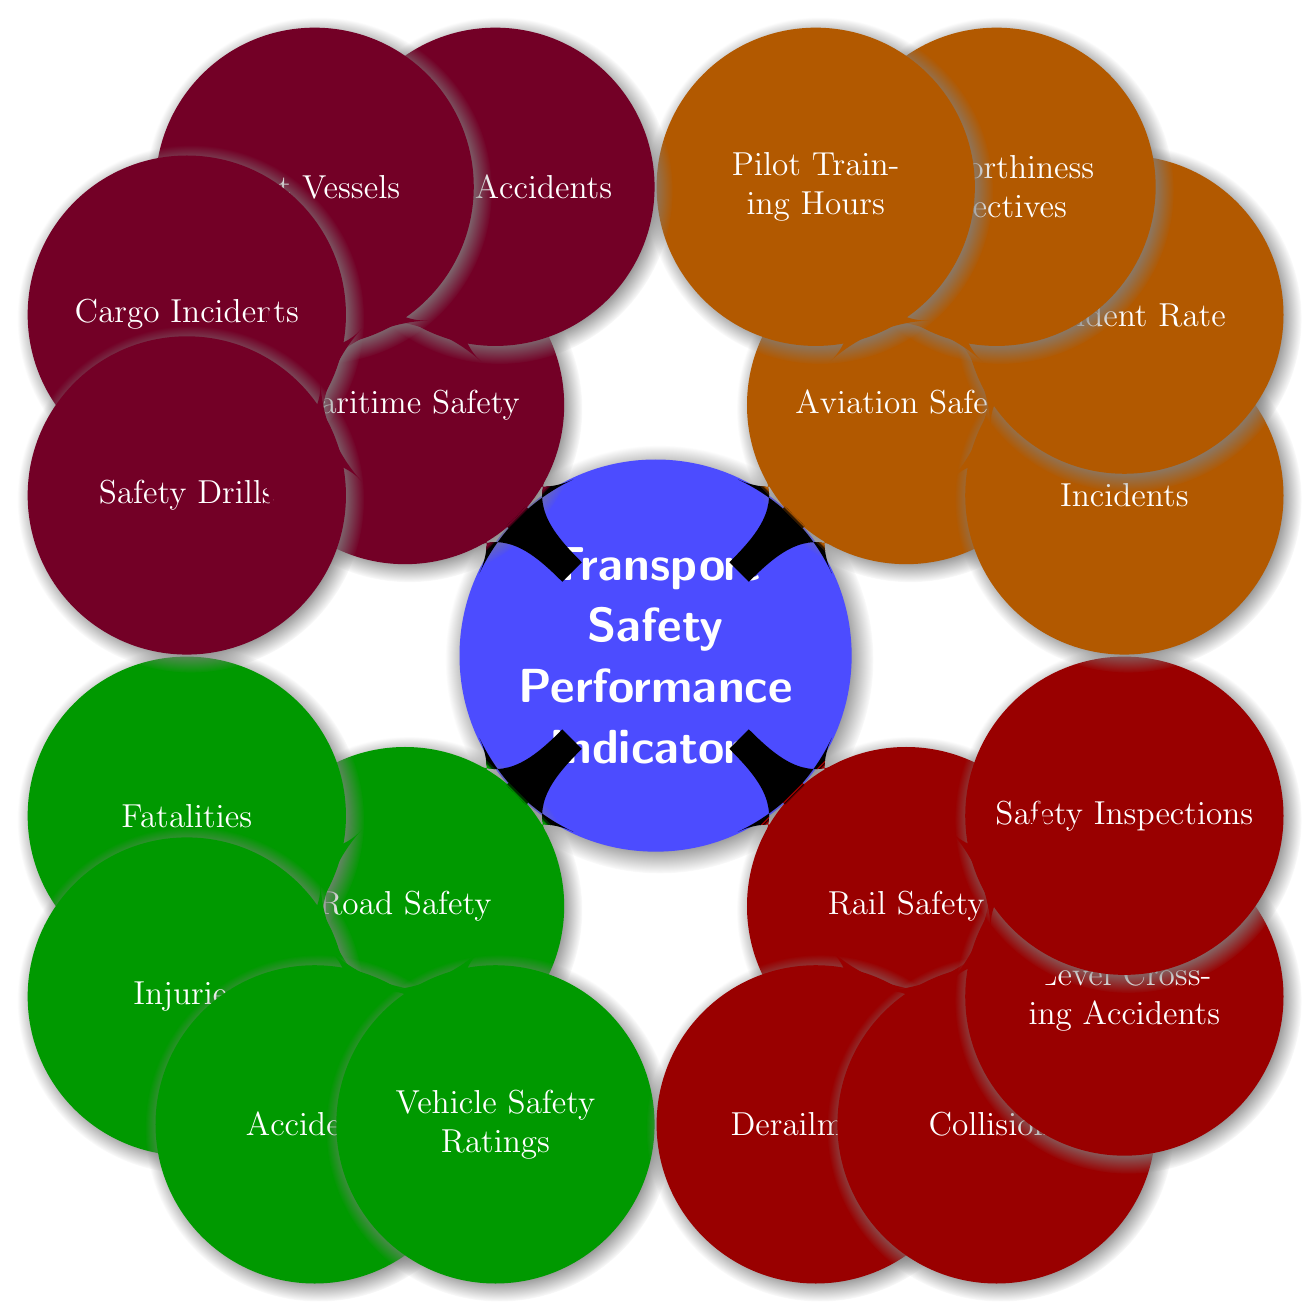What are the four categories of transport safety performance indicators? The mind map displays four main categories: Road Safety, Rail Safety, Aviation Safety, and Maritime Safety. These are the top-level nodes under the root concept.
Answer: Road Safety, Rail Safety, Aviation Safety, Maritime Safety How many indicators are associated with Road Safety? The Road Safety branch has four indicators listed: Fatalities, Injuries, Accidents, and Vehicle Safety Ratings. Therefore, the count of nodes under this category is four.
Answer: 4 What specific type of incident is measured under Rail Safety? There are several indicators under Rail Safety, one of which is "Collisions," which specifically measures train collisions per year. This is directly indicated in the Rail Safety category.
Answer: Collisions Which category includes the indicator for Pilot Training Hours? Pilot Training Hours is listed under the Aviation Safety category, indicating it pertains specifically to that mode of transportation. This information can be found in the Aviation Safety section of the mind map.
Answer: Aviation Safety How many unique indicators are listed for Maritime Safety? The Maritime Safety node includes four distinct indicators: Vessel Accidents, Lost Vessels, Cargo Incidents, and Safety Drills, totaling four unique indicators.
Answer: 4 What is the relationship between the indicator "Safety Inspections" and Rail Safety? "Safety Inspections" is one of the four indicators specifically under the Rail Safety category, indicating it is crucial for assessing the safety within the rail transport sector.
Answer: Safety Inspections is under Rail Safety What overall trends can be observed in terms of categories represented in the mind map? The mind map comprehensively represents four main modes of transport, each with its own set of performance indicators, indicating that transport safety is a multifaceted area requiring attention across various transport sectors. This highlights the need for tailored safety measures specific to each mode of transportation.
Answer: Four categories are represented Which category addresses the issue of Cargo Incidents? Cargo Incidents are specifically measured under the Maritime Safety category, making it clear that this type of incident pertains to maritime transport. This can be traced directly back to the Maritime Safety section.
Answer: Maritime Safety 